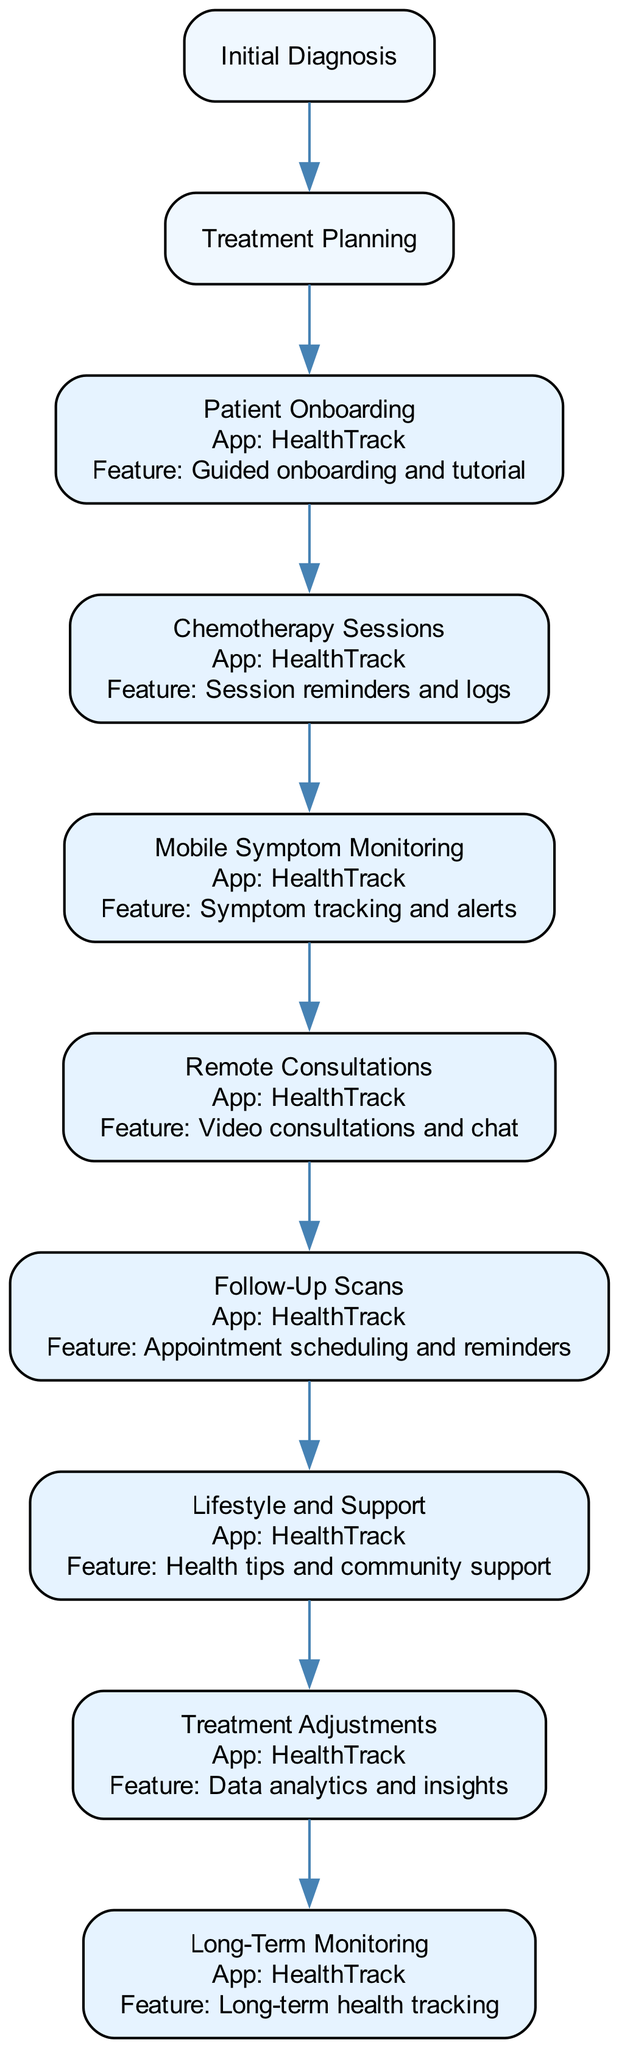What is the first step in the workflow? The first step listed in the workflow is "Initial Diagnosis." This is the first node in the diagram and initiates the treatment process.
Answer: Initial Diagnosis How many steps involve mobile monitoring? By reviewing the steps, there are a total of 7 steps that mention mobile monitoring features, specifically steps 3 through 10.
Answer: 7 What feature is associated with the Patient Onboarding step? In the Patient Onboarding step, the associated feature of the app is "Guided onboarding and tutorial," which helps patients get familiar with mobile health monitoring.
Answer: Guided onboarding and tutorial Which step follows the Chemotherapy Sessions? After the Chemotherapy Sessions, the next step in the workflow is "Mobile Symptom Monitoring," which allows patients to report symptoms after their sessions.
Answer: Mobile Symptom Monitoring What is the main function of the HealthTrack app in Remote Consultations? The main function of the HealthTrack app in Remote Consultations is to provide "Video consultations and chat." This allows oncologists to interact with patients remotely using the app for better continuity of care.
Answer: Video consultations and chat How does the workflow address long-term health? The step titled "Long-Term Monitoring" is specifically designed to ensure continued observation of the patient’s health to prevent any recurrence of cancer, emphasizing the importance of ongoing support.
Answer: Long-Term Monitoring Which step is directly connected to Treatment Adjustments? The "Follow-Up Scans" step is directly connected to "Treatment Adjustments" as the results from scans inform the adjustments necessary in the patient's treatment plan.
Answer: Follow-Up Scans What is the primary concern discussed in the Lifestyle and Support step? The primary concern addressed in the Lifestyle and Support step is the ongoing support that includes diet, physical activity, and mental health monitoring to improve patient outcomes during and after treatment.
Answer: Ongoing support What is the last step in the oncology treatment workflow? The last step in the workflow is "Long-Term Monitoring," which indicates the importance of follow-up procedures to ensure the patient's health is maintained post-treatment.
Answer: Long-Term Monitoring 